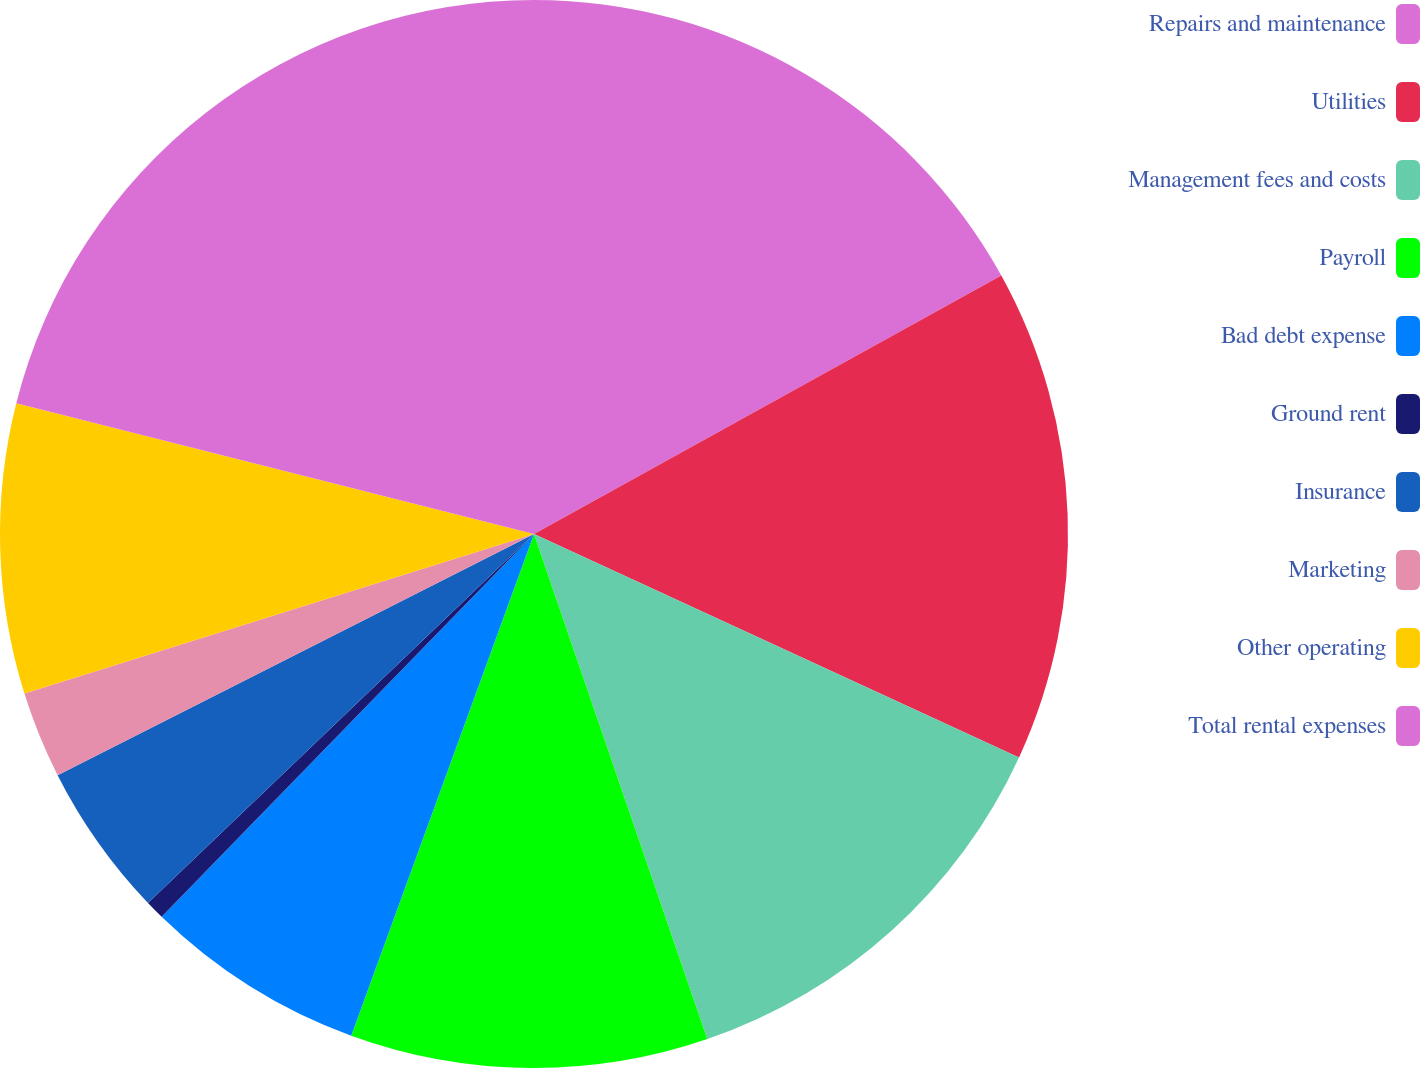<chart> <loc_0><loc_0><loc_500><loc_500><pie_chart><fcel>Repairs and maintenance<fcel>Utilities<fcel>Management fees and costs<fcel>Payroll<fcel>Bad debt expense<fcel>Ground rent<fcel>Insurance<fcel>Marketing<fcel>Other operating<fcel>Total rental expenses<nl><fcel>16.96%<fcel>14.91%<fcel>12.87%<fcel>10.82%<fcel>6.72%<fcel>0.58%<fcel>4.68%<fcel>2.63%<fcel>8.77%<fcel>21.06%<nl></chart> 